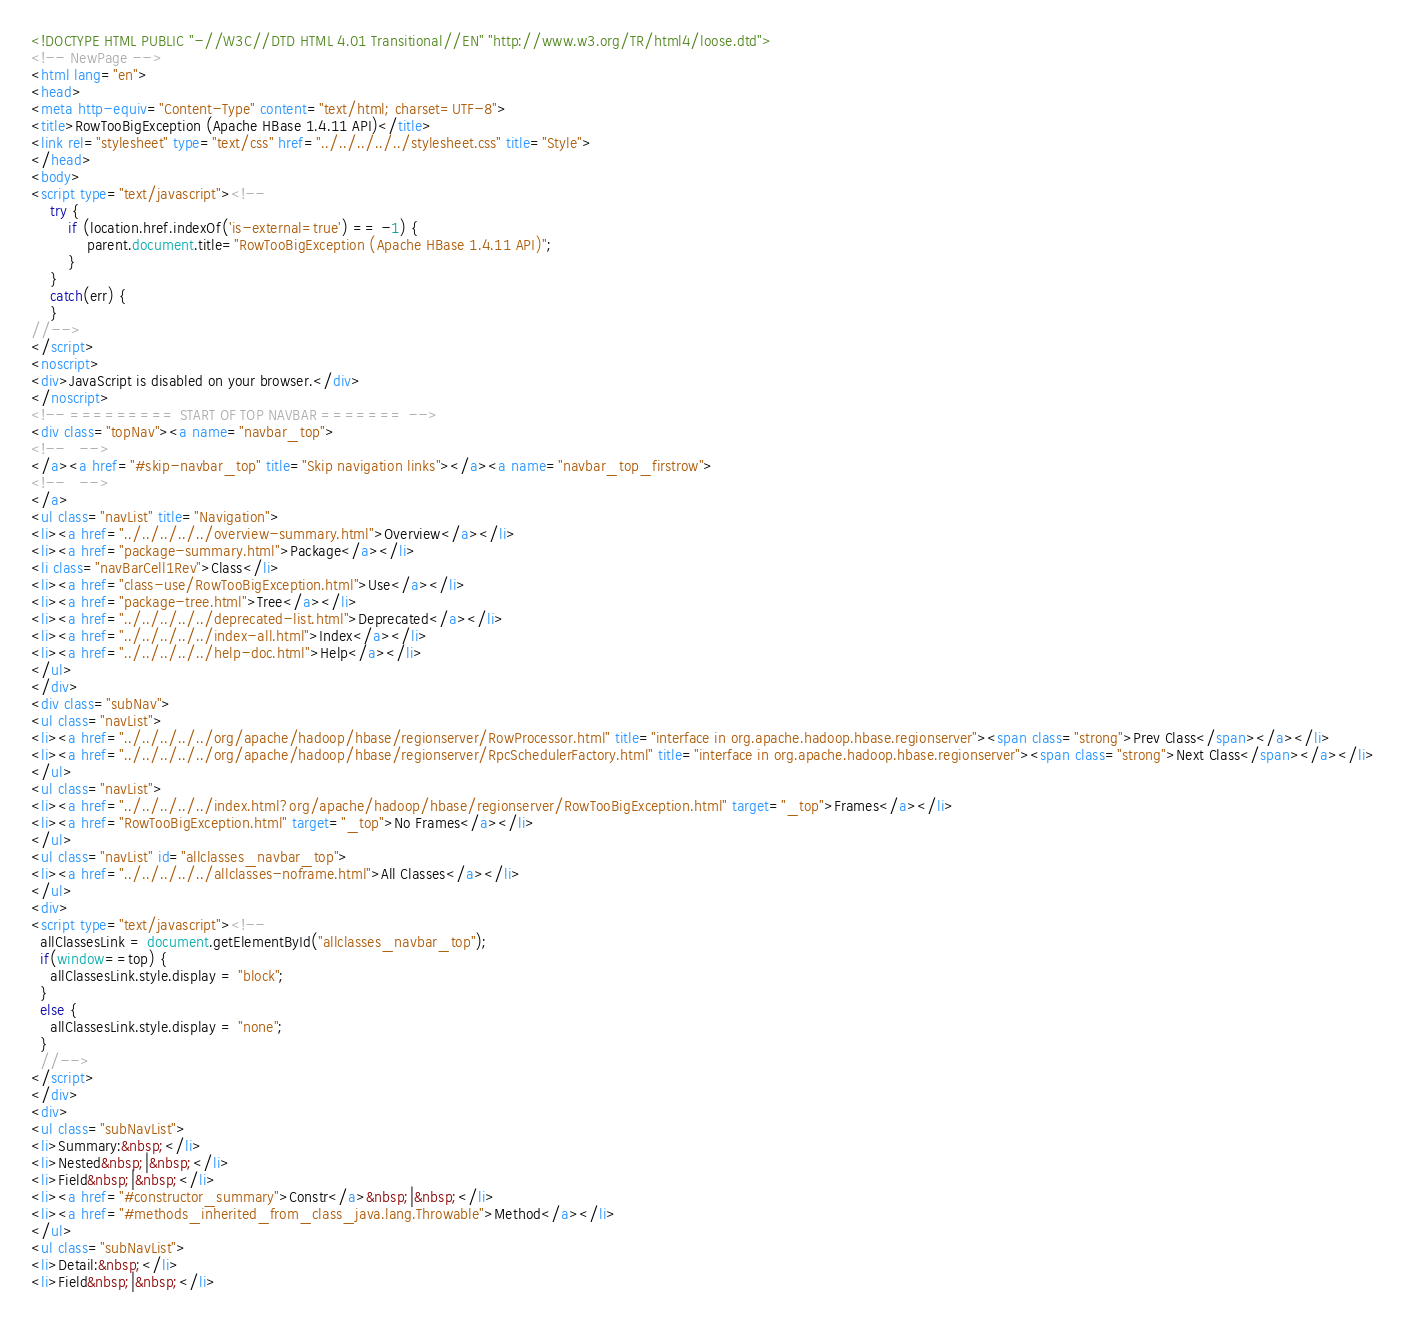<code> <loc_0><loc_0><loc_500><loc_500><_HTML_><!DOCTYPE HTML PUBLIC "-//W3C//DTD HTML 4.01 Transitional//EN" "http://www.w3.org/TR/html4/loose.dtd">
<!-- NewPage -->
<html lang="en">
<head>
<meta http-equiv="Content-Type" content="text/html; charset=UTF-8">
<title>RowTooBigException (Apache HBase 1.4.11 API)</title>
<link rel="stylesheet" type="text/css" href="../../../../../stylesheet.css" title="Style">
</head>
<body>
<script type="text/javascript"><!--
    try {
        if (location.href.indexOf('is-external=true') == -1) {
            parent.document.title="RowTooBigException (Apache HBase 1.4.11 API)";
        }
    }
    catch(err) {
    }
//-->
</script>
<noscript>
<div>JavaScript is disabled on your browser.</div>
</noscript>
<!-- ========= START OF TOP NAVBAR ======= -->
<div class="topNav"><a name="navbar_top">
<!--   -->
</a><a href="#skip-navbar_top" title="Skip navigation links"></a><a name="navbar_top_firstrow">
<!--   -->
</a>
<ul class="navList" title="Navigation">
<li><a href="../../../../../overview-summary.html">Overview</a></li>
<li><a href="package-summary.html">Package</a></li>
<li class="navBarCell1Rev">Class</li>
<li><a href="class-use/RowTooBigException.html">Use</a></li>
<li><a href="package-tree.html">Tree</a></li>
<li><a href="../../../../../deprecated-list.html">Deprecated</a></li>
<li><a href="../../../../../index-all.html">Index</a></li>
<li><a href="../../../../../help-doc.html">Help</a></li>
</ul>
</div>
<div class="subNav">
<ul class="navList">
<li><a href="../../../../../org/apache/hadoop/hbase/regionserver/RowProcessor.html" title="interface in org.apache.hadoop.hbase.regionserver"><span class="strong">Prev Class</span></a></li>
<li><a href="../../../../../org/apache/hadoop/hbase/regionserver/RpcSchedulerFactory.html" title="interface in org.apache.hadoop.hbase.regionserver"><span class="strong">Next Class</span></a></li>
</ul>
<ul class="navList">
<li><a href="../../../../../index.html?org/apache/hadoop/hbase/regionserver/RowTooBigException.html" target="_top">Frames</a></li>
<li><a href="RowTooBigException.html" target="_top">No Frames</a></li>
</ul>
<ul class="navList" id="allclasses_navbar_top">
<li><a href="../../../../../allclasses-noframe.html">All Classes</a></li>
</ul>
<div>
<script type="text/javascript"><!--
  allClassesLink = document.getElementById("allclasses_navbar_top");
  if(window==top) {
    allClassesLink.style.display = "block";
  }
  else {
    allClassesLink.style.display = "none";
  }
  //-->
</script>
</div>
<div>
<ul class="subNavList">
<li>Summary:&nbsp;</li>
<li>Nested&nbsp;|&nbsp;</li>
<li>Field&nbsp;|&nbsp;</li>
<li><a href="#constructor_summary">Constr</a>&nbsp;|&nbsp;</li>
<li><a href="#methods_inherited_from_class_java.lang.Throwable">Method</a></li>
</ul>
<ul class="subNavList">
<li>Detail:&nbsp;</li>
<li>Field&nbsp;|&nbsp;</li></code> 